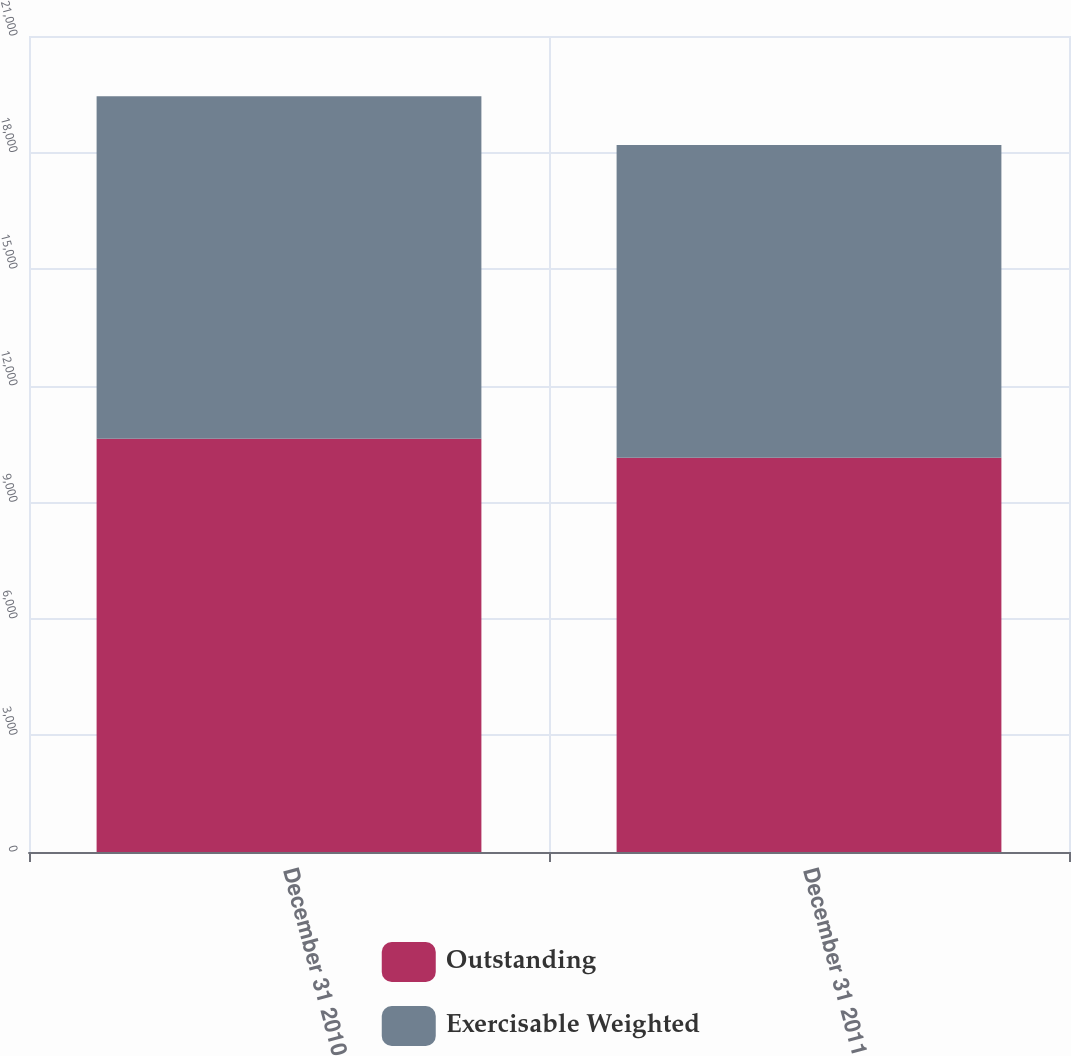Convert chart. <chart><loc_0><loc_0><loc_500><loc_500><stacked_bar_chart><ecel><fcel>December 31 2010<fcel>December 31 2011<nl><fcel>Outstanding<fcel>10636<fcel>10148<nl><fcel>Exercisable Weighted<fcel>8815<fcel>8049<nl></chart> 